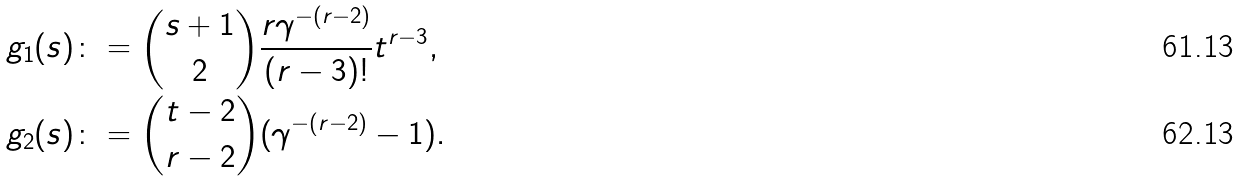<formula> <loc_0><loc_0><loc_500><loc_500>g _ { 1 } ( s ) & \colon = { s + 1 \choose 2 } \frac { r \gamma ^ { - ( r - 2 ) } } { ( r - 3 ) ! } t ^ { r - 3 } , \\ g _ { 2 } ( s ) & \colon = { t - 2 \choose r - 2 } ( \gamma ^ { - ( r - 2 ) } - 1 ) .</formula> 